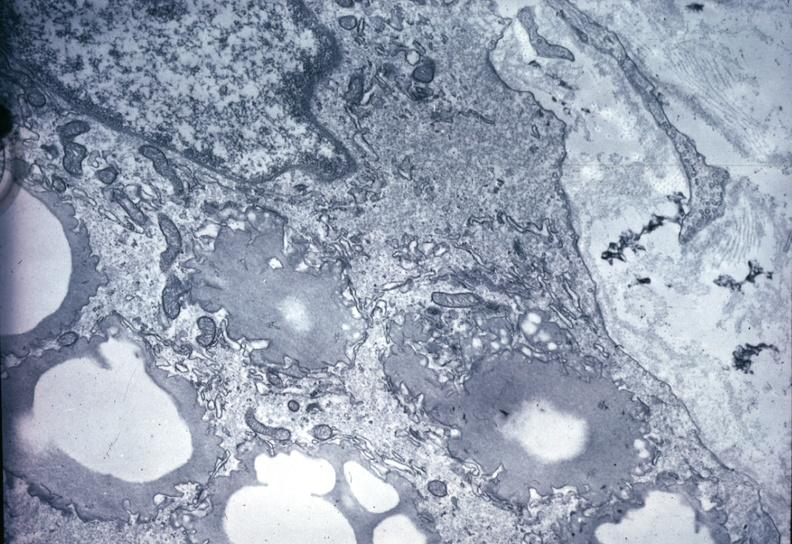what is present?
Answer the question using a single word or phrase. Cardiovascular 